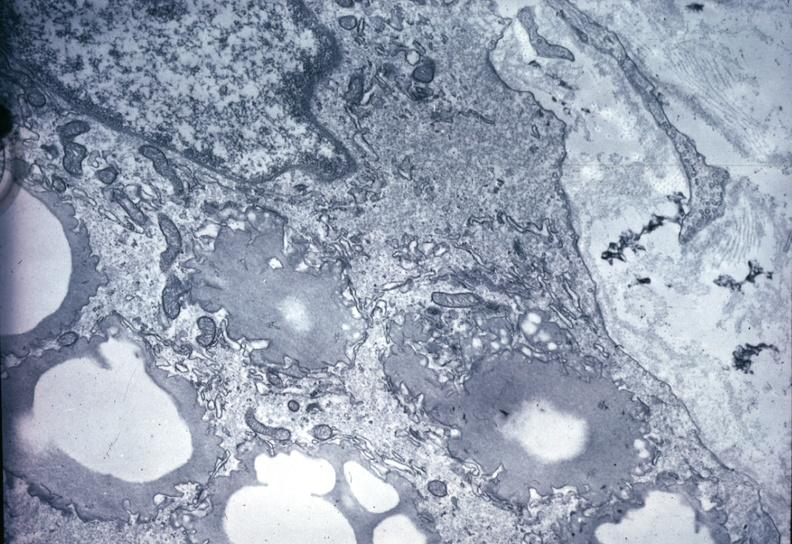what is present?
Answer the question using a single word or phrase. Cardiovascular 